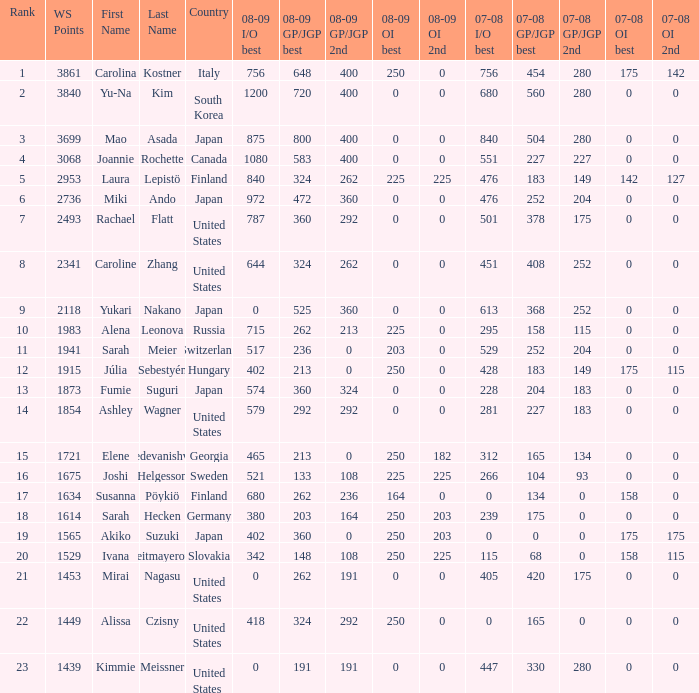Give me the full table as a dictionary. {'header': ['Rank', 'WS Points', 'First Name', 'Last Name', 'Country', '08-09 I/O best', '08-09 GP/JGP best', '08-09 GP/JGP 2nd', '08-09 OI best', '08-09 OI 2nd', '07-08 I/O best', '07-08 GP/JGP best', '07-08 GP/JGP 2nd', '07-08 OI best', '07-08 OI 2nd'], 'rows': [['1', '3861', 'Carolina', 'Kostner', 'Italy', '756', '648', '400', '250', '0', '756', '454', '280', '175', '142'], ['2', '3840', 'Yu-Na', 'Kim', 'South Korea', '1200', '720', '400', '0', '0', '680', '560', '280', '0', '0'], ['3', '3699', 'Mao', 'Asada', 'Japan', '875', '800', '400', '0', '0', '840', '504', '280', '0', '0'], ['4', '3068', 'Joannie', 'Rochette', 'Canada', '1080', '583', '400', '0', '0', '551', '227', '227', '0', '0'], ['5', '2953', 'Laura', 'Lepistö', 'Finland', '840', '324', '262', '225', '225', '476', '183', '149', '142', '127'], ['6', '2736', 'Miki', 'Ando', 'Japan', '972', '472', '360', '0', '0', '476', '252', '204', '0', '0'], ['7', '2493', 'Rachael', 'Flatt', 'United States', '787', '360', '292', '0', '0', '501', '378', '175', '0', '0'], ['8', '2341', 'Caroline', 'Zhang', 'United States', '644', '324', '262', '0', '0', '451', '408', '252', '0', '0'], ['9', '2118', 'Yukari', 'Nakano', 'Japan', '0', '525', '360', '0', '0', '613', '368', '252', '0', '0'], ['10', '1983', 'Alena', 'Leonova', 'Russia', '715', '262', '213', '225', '0', '295', '158', '115', '0', '0'], ['11', '1941', 'Sarah', 'Meier', 'Switzerland', '517', '236', '0', '203', '0', '529', '252', '204', '0', '0'], ['12', '1915', 'Júlia', 'Sebestyén', 'Hungary', '402', '213', '0', '250', '0', '428', '183', '149', '175', '115'], ['13', '1873', 'Fumie', 'Suguri', 'Japan', '574', '360', '324', '0', '0', '228', '204', '183', '0', '0'], ['14', '1854', 'Ashley', 'Wagner', 'United States', '579', '292', '292', '0', '0', '281', '227', '183', '0', '0'], ['15', '1721', 'Elene', 'Gedevanishvili', 'Georgia', '465', '213', '0', '250', '182', '312', '165', '134', '0', '0'], ['16', '1675', 'Joshi', 'Helgesson', 'Sweden', '521', '133', '108', '225', '225', '266', '104', '93', '0', '0'], ['17', '1634', 'Susanna', 'Pöykiö', 'Finland', '680', '262', '236', '164', '0', '0', '134', '0', '158', '0'], ['18', '1614', 'Sarah', 'Hecken', 'Germany', '380', '203', '164', '250', '203', '239', '175', '0', '0', '0'], ['19', '1565', 'Akiko', 'Suzuki', 'Japan', '402', '360', '0', '250', '203', '0', '0', '0', '175', '175'], ['20', '1529', 'Ivana', 'Reitmayerova', 'Slovakia', '342', '148', '108', '250', '225', '115', '68', '0', '158', '115'], ['21', '1453', 'Mirai', 'Nagasu', 'United States', '0', '262', '191', '0', '0', '405', '420', '175', '0', '0'], ['22', '1449', 'Alissa', 'Czisny', 'United States', '418', '324', '292', '250', '0', '0', '165', '0', '0', '0'], ['23', '1439', 'Kimmie', 'Meissner', 'United States', '0', '191', '191', '0', '0', '447', '330', '280', '0', '0']]} What is the total 07-08 gp/jgp 2nd with the name mao asada 280.0. 